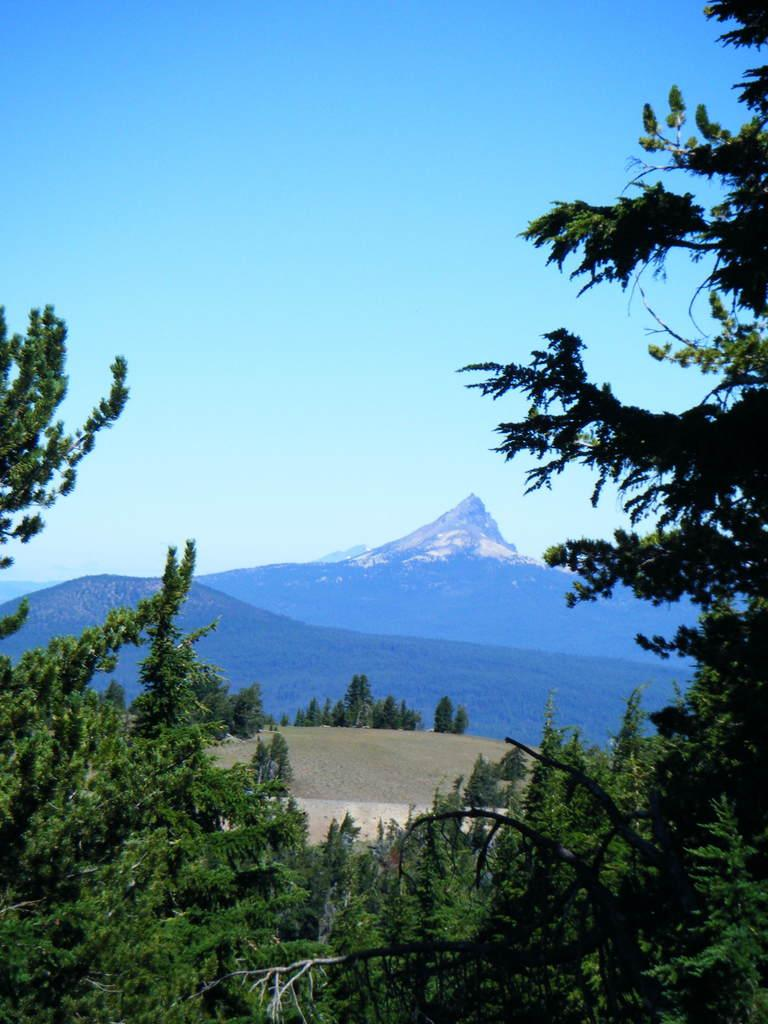What type of natural features can be seen in the image? There are trees and mountains in the image. What is visible in the background of the image? The sky is visible in the background of the image. What type of bait is being used to catch fish in the image? There is no fishing or bait present in the image; it features trees, mountains, and the sky. What is the mass of the largest tree in the image? The mass of the trees cannot be determined from the image, as it only provides a visual representation of the trees and not their physical properties. 